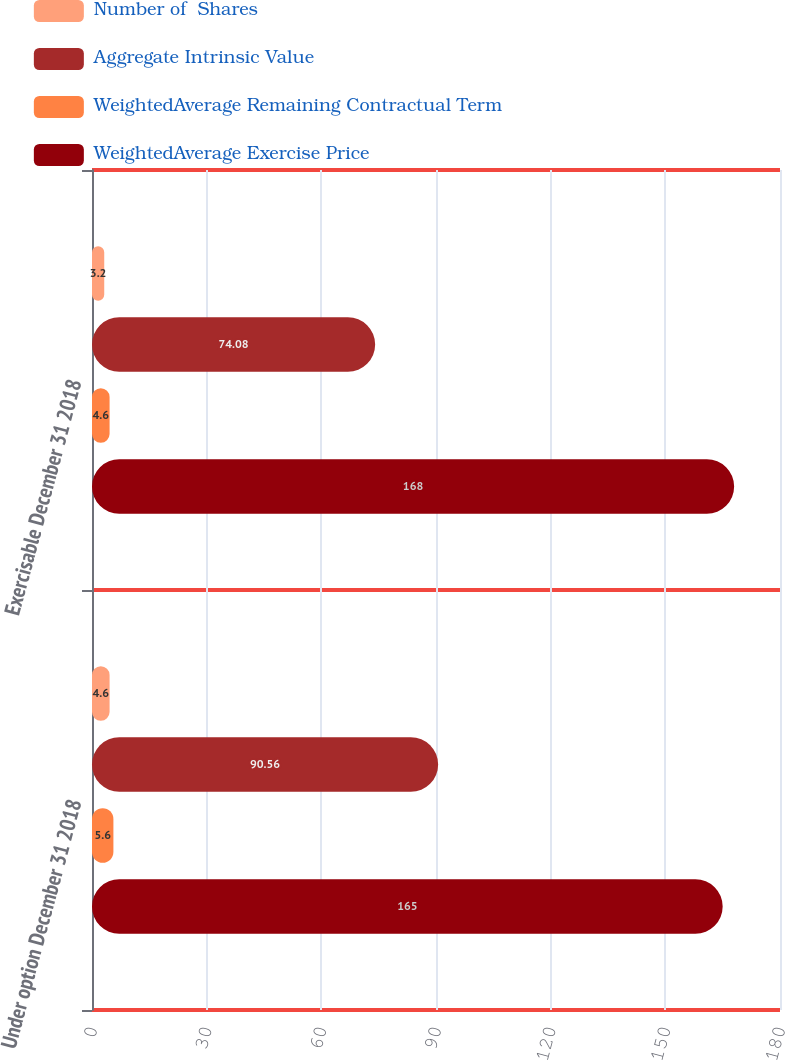<chart> <loc_0><loc_0><loc_500><loc_500><stacked_bar_chart><ecel><fcel>Under option December 31 2018<fcel>Exercisable December 31 2018<nl><fcel>Number of  Shares<fcel>4.6<fcel>3.2<nl><fcel>Aggregate Intrinsic Value<fcel>90.56<fcel>74.08<nl><fcel>WeightedAverage Remaining Contractual Term<fcel>5.6<fcel>4.6<nl><fcel>WeightedAverage Exercise Price<fcel>165<fcel>168<nl></chart> 